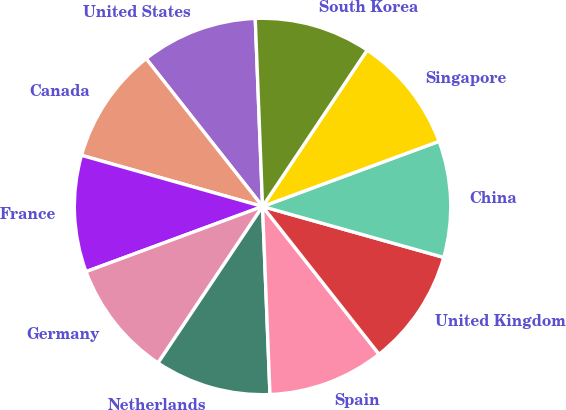Convert chart. <chart><loc_0><loc_0><loc_500><loc_500><pie_chart><fcel>United States<fcel>Canada<fcel>France<fcel>Germany<fcel>Netherlands<fcel>Spain<fcel>United Kingdom<fcel>China<fcel>Singapore<fcel>South Korea<nl><fcel>10.0%<fcel>10.0%<fcel>10.01%<fcel>10.0%<fcel>10.0%<fcel>10.0%<fcel>10.01%<fcel>9.99%<fcel>9.99%<fcel>10.0%<nl></chart> 